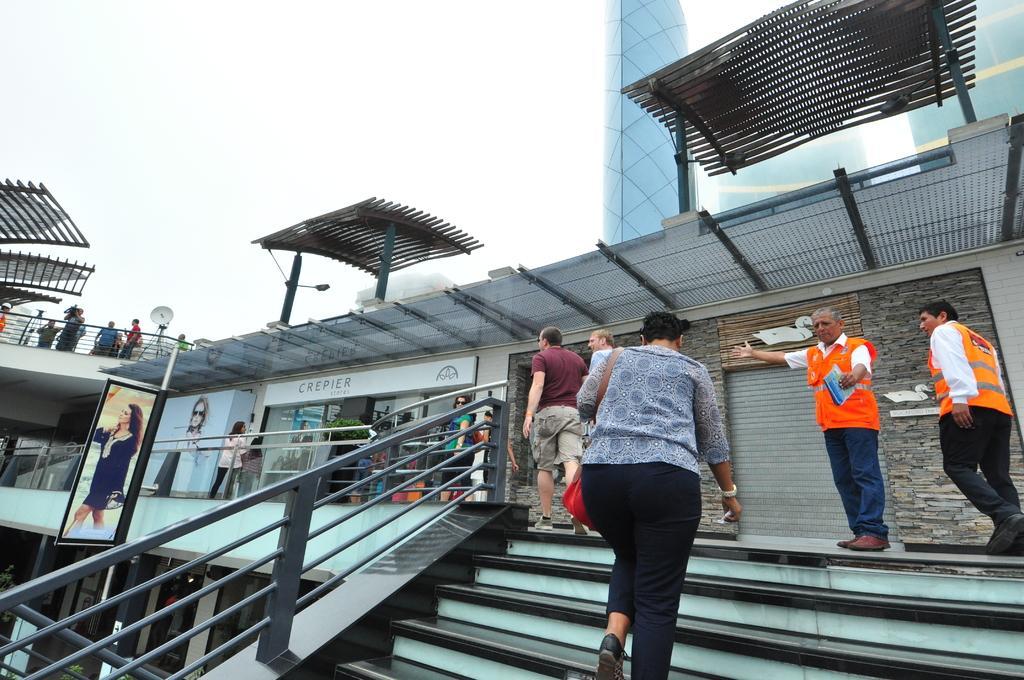How would you summarize this image in a sentence or two? In this picture we can see shelters and background is blue, it seems like a pillar. In this picture we can see a store and boards. We can see people wearing orange jackets. We can see people are walking. we can see a person climbing the stairs. On the left side we can see a railing and green leaves. In the top left corner we can see people standing and a dash panel. 